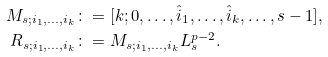Convert formula to latex. <formula><loc_0><loc_0><loc_500><loc_500>M _ { s ; i _ { 1 } , \dots , i _ { k } } & \colon = [ k ; 0 , \dots , \hat { i } _ { 1 } , \dots , \hat { i } _ { k } , \dots , s - 1 ] , \\ R _ { s ; i _ { 1 } , \dots , i _ { k } } & \colon = M _ { s ; i _ { 1 } , \dots , i _ { k } } L _ { s } ^ { p - 2 } .</formula> 